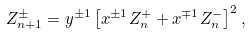Convert formula to latex. <formula><loc_0><loc_0><loc_500><loc_500>Z _ { n + 1 } ^ { \pm } = y ^ { \pm 1 } \left [ x ^ { \pm 1 } Z _ { n } ^ { + } + x ^ { \mp 1 } Z _ { n } ^ { - } \right ] ^ { 2 } ,</formula> 